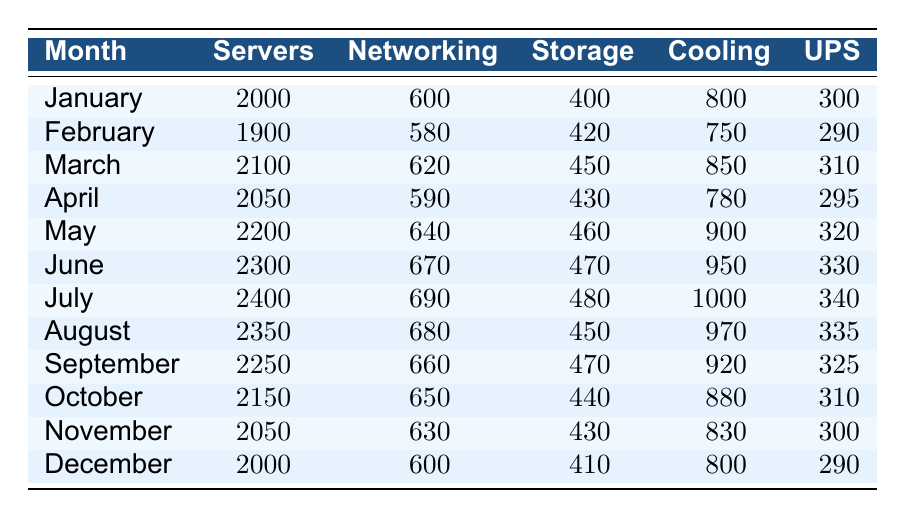What was the total energy consumption from servers in June? In June, the value for servers is 2300. There are no additional calculations needed since we're looking for just one specific value from the table.
Answer: 2300 What was the average cooling consumption for the first half of the year (January to June)? To find the average cooling, first sum the cooling values from January to June: 800 + 750 + 850 + 780 + 900 + 950 = 5030. There are 6 months, so the average is 5030 / 6 = 838.33.
Answer: 838.33 Did the energy consumption for networking increase every month? To determine this, we should check the values for networking month by month: January (600), February (580), March (620), April (590), May (640), June (670), July (690), August (680), September (660), October (650), November (630), December (600). The values fluctuate and do not increase each month, specifically from January to February and July to August, which shows decreases.
Answer: No What is the month with the highest cooling consumption, and what is that value? By scanning the cooling values: January (800), February (750), March (850), April (780), May (900), June (950), July (1000), August (970), September (920), October (880), November (830), December (800), the month with the highest value is July with a value of 1000.
Answer: July, 1000 What was the total energy consumption for storage across all months? To find this total, sum the storage values: 400 + 420 + 450 + 430 + 460 + 470 + 480 + 450 + 470 + 440 + 430 + 410 = 5400. This involves simple addition of the values from each month.
Answer: 5400 Which month had the lowest energy consumption for UPS, and what was that value? By reviewing the UPS values from the table: January (300), February (290), March (310), April (295), May (320), June (330), July (340), August (335), September (325), October (310), November (300), December (290), the lowest consumption for UPS was in February and December, both with a value of 290.
Answer: February and December, 290 What was the percentage increase in the number of servers from January to July? First, find the number of servers in January (2000) and July (2400). Calculate the difference: 2400 - 2000 = 400. Then divide by the January value: 400 / 2000 * 100 = 20%. This gives us the percentage increase in server consumption over that period.
Answer: 20% What was the total energy consumption from all equipment types in October? Sum the values for October: 2150 (servers) + 650 (networking) + 440 (storage) + 880 (cooling) + 310 (UPS) = 4480. Each value is taken directly from the table for that month to provide the total.
Answer: 4480 